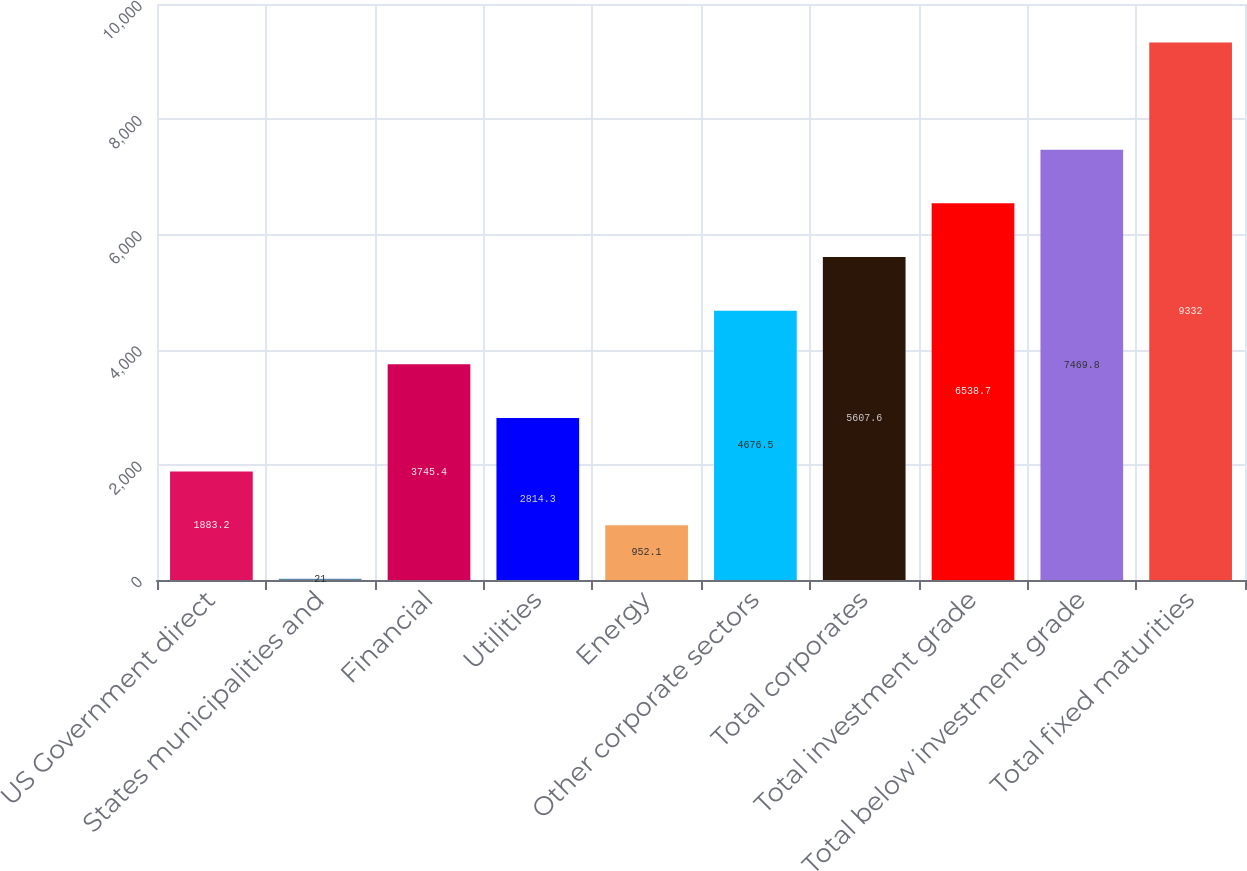Convert chart. <chart><loc_0><loc_0><loc_500><loc_500><bar_chart><fcel>US Government direct<fcel>States municipalities and<fcel>Financial<fcel>Utilities<fcel>Energy<fcel>Other corporate sectors<fcel>Total corporates<fcel>Total investment grade<fcel>Total below investment grade<fcel>Total fixed maturities<nl><fcel>1883.2<fcel>21<fcel>3745.4<fcel>2814.3<fcel>952.1<fcel>4676.5<fcel>5607.6<fcel>6538.7<fcel>7469.8<fcel>9332<nl></chart> 